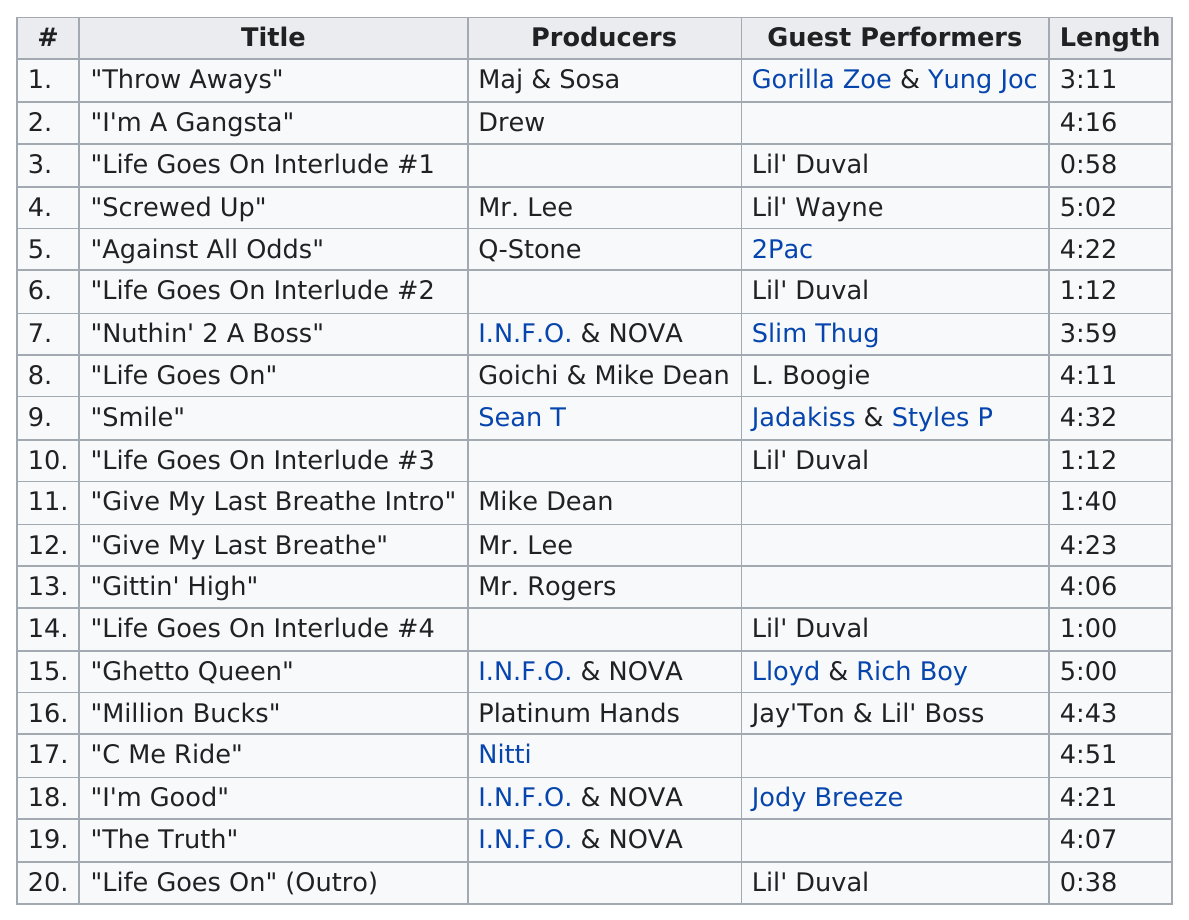Identify some key points in this picture. I.N.F.O. & NOVA are the producers who produced the majority of songs on this record. The longest track on the album is titled 'Screwed Up,' The track after the fourth life goes on interlude is titled "Ghetto Queen. There are 5 tracks on the album that do not have a producer listed explicitly. The number of tracks featuring 2Pac is 1. 